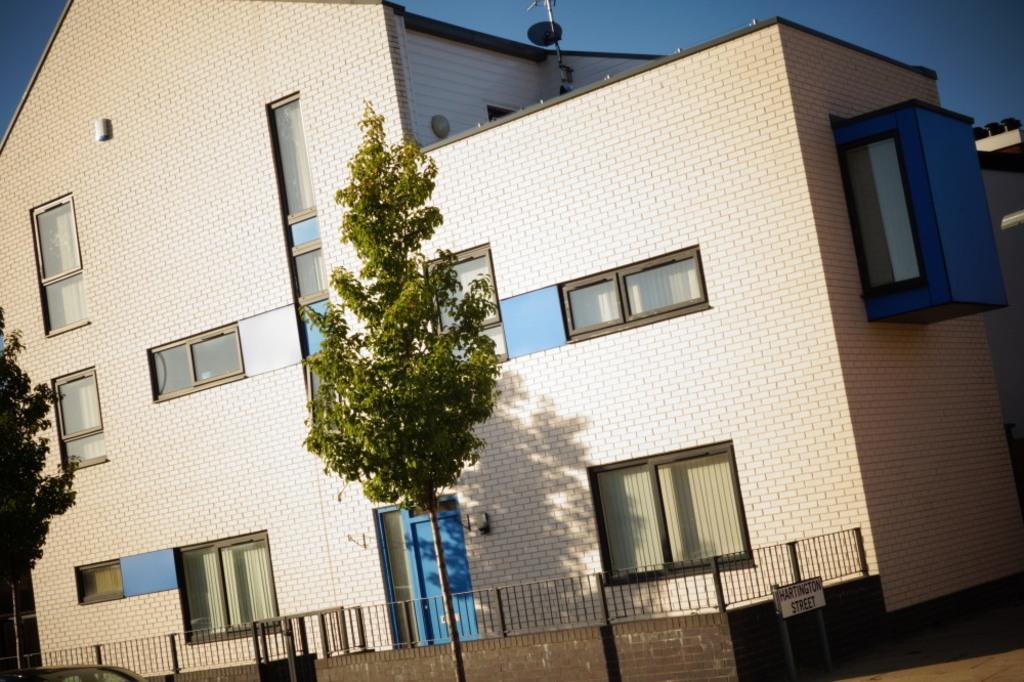Can you describe this image briefly? In this picture there is a building. There are glass windows, door and railing to the building. On the building there is dish antenna. There is a tree in front of the building. To the right corner there is a name board with text on it. To the top of the image there is sky. 